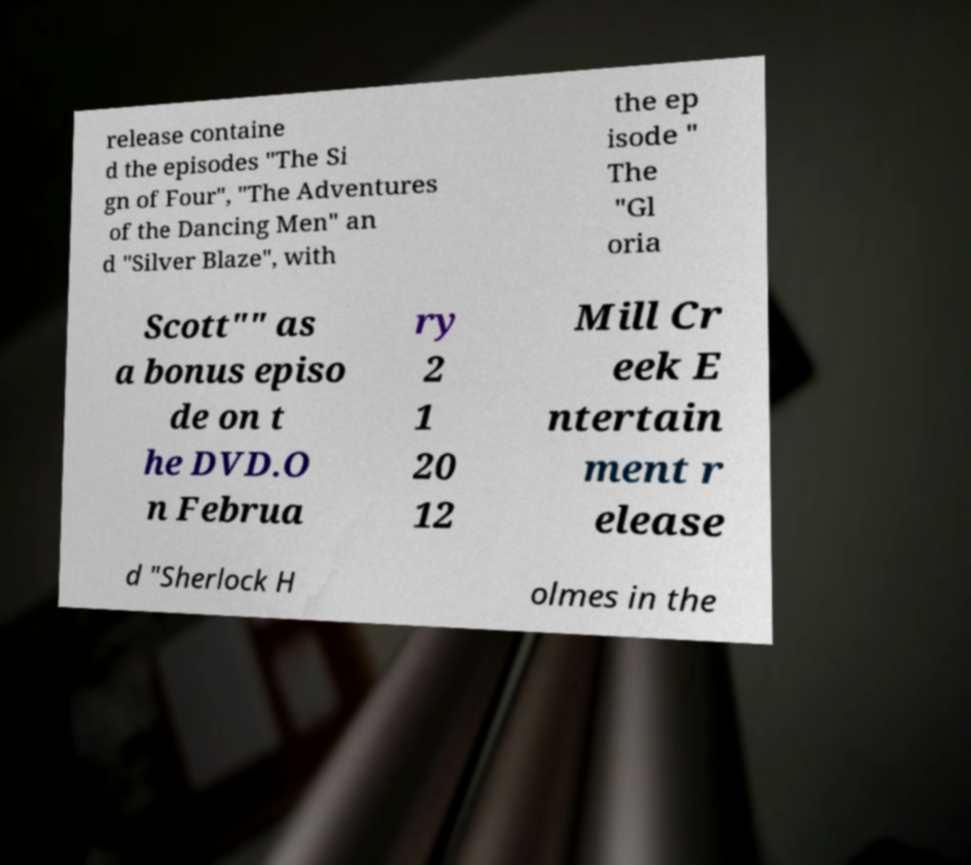Please identify and transcribe the text found in this image. release containe d the episodes "The Si gn of Four", "The Adventures of the Dancing Men" an d "Silver Blaze", with the ep isode " The "Gl oria Scott"" as a bonus episo de on t he DVD.O n Februa ry 2 1 20 12 Mill Cr eek E ntertain ment r elease d "Sherlock H olmes in the 